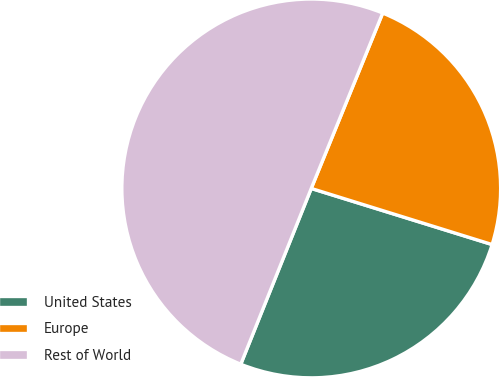Convert chart to OTSL. <chart><loc_0><loc_0><loc_500><loc_500><pie_chart><fcel>United States<fcel>Europe<fcel>Rest of World<nl><fcel>26.28%<fcel>23.63%<fcel>50.09%<nl></chart> 